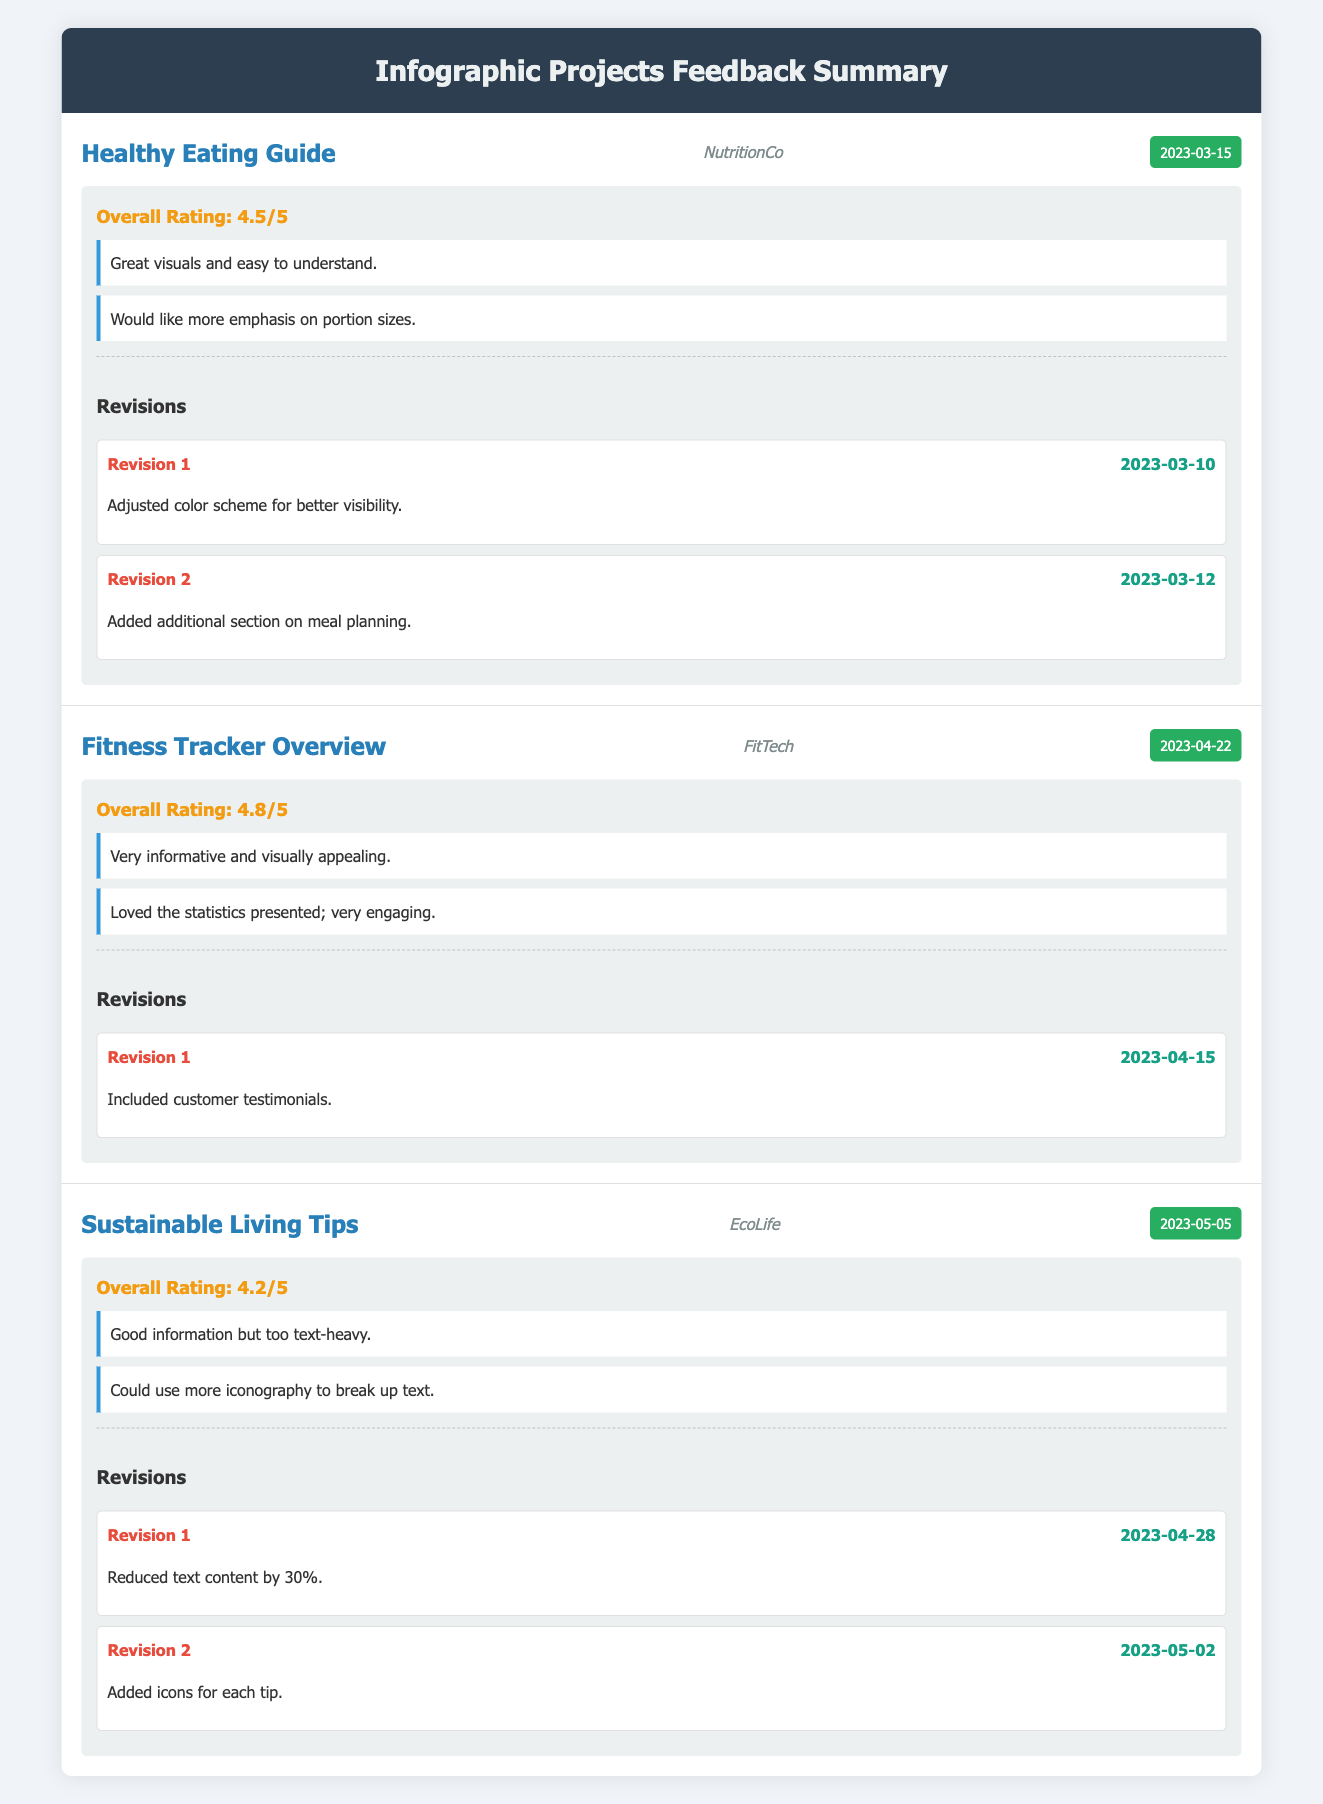What is the overall rating for the "Fitness Tracker Overview" project? The overall rating for the "Fitness Tracker Overview" project is directly stated in the table under the feedback section. It reads "Overall Rating: 4.8/5".
Answer: 4.8 How many comments did the client provide for the "Healthy Eating Guide"? In the table, under the feedback section for the "Healthy Eating Guide", there are two comments listed: "Great visuals and easy to understand." and "Would like more emphasis on portion sizes." Thus, the total number of comments is two.
Answer: 2 Did EcoLife provide positive feedback on the "Sustainable Living Tips" project? Yes. The feedback indicates that while there were some critiques, such as it being too text-heavy, it still retained a positive overall rating of 4.2/5. This suggests that the overall impression was mostly positive.
Answer: Yes What are the total number of revisions made for the "Healthy Eating Guide"? The table provides two revisions in the feedback section for the project titled "Healthy Eating Guide”. These revisions are listed as Revision 1 and Revision 2. Thus, the total number of revisions is two.
Answer: 2 What is the average overall rating of all the infographic projects? To calculate the average overall rating, sum the ratings: 4.5 + 4.8 + 4.2 = 13.5. Next, divide by the number of projects, which is 3. Therefore, the average is 13.5 / 3 = 4.5.
Answer: 4.5 Which client requested the addition of customer testimonials in their project? The table indicates that the client "FitTech" requested the inclusion of customer testimonials, which is listed in the revisions for the "Fitness Tracker Overview" project.
Answer: FitTech How many revisions did EcoLife request for its project? EcoLife requested two revisions as per the feedback listed for the "Sustainable Living Tips" project, which are Revision 1 and Revision 2 in the revisions section.
Answer: 2 Was any project rated lower than 4.5? Yes, the "Sustainable Living Tips" project received a rating of 4.2, which is indeed lower than 4.5.
Answer: Yes What change was made in the first revision of the "Sustainable Living Tips" project? The first revision listed for the "Sustainable Living Tips" project states that "Reduced text content by 30%," which highlights a significant change to address feedback regarding text heaviness.
Answer: Reduced text content by 30% What was the highest overall rating among the projects listed? Upon reviewing the overall ratings for all projects, "Fitness Tracker Overview" has the highest rating of 4.8. This is higher than the other two projects.
Answer: 4.8 